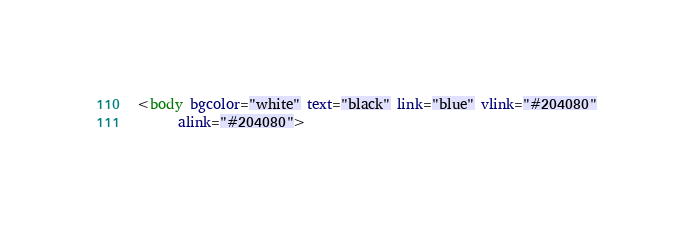<code> <loc_0><loc_0><loc_500><loc_500><_HTML_><body bgcolor="white" text="black" link="blue" vlink="#204080"
      alink="#204080"></code> 